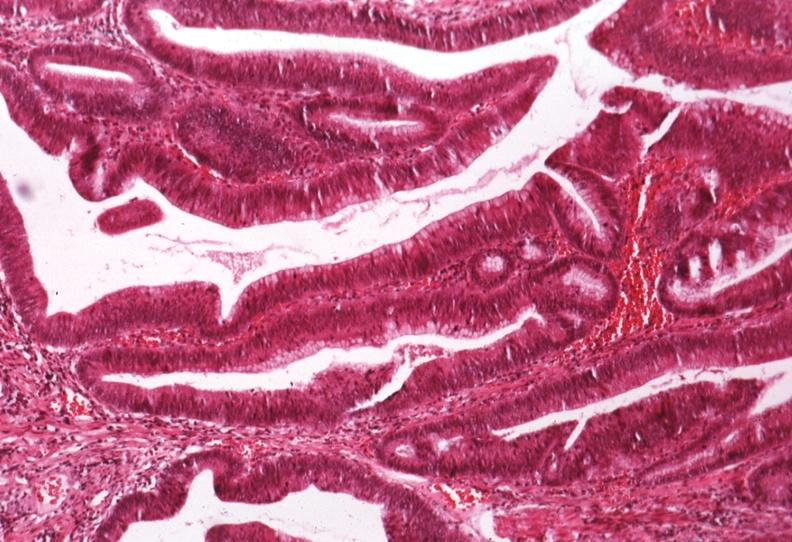what is present?
Answer the question using a single word or phrase. Colon 